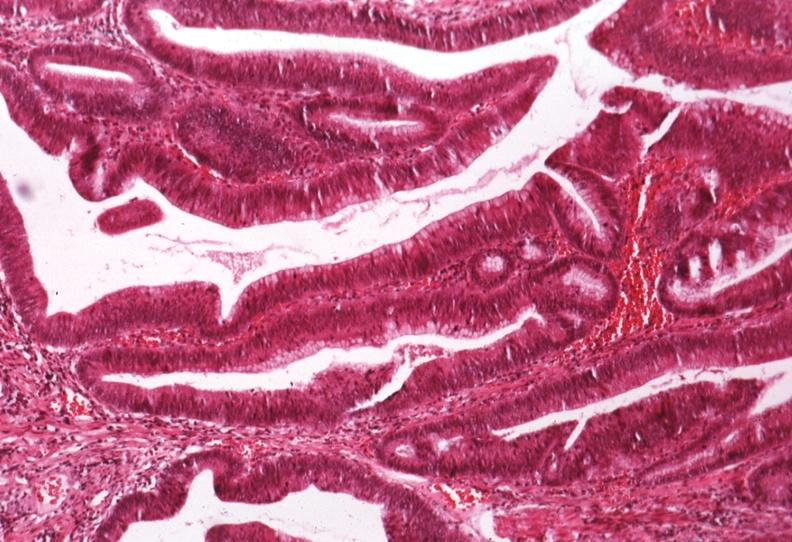what is present?
Answer the question using a single word or phrase. Colon 